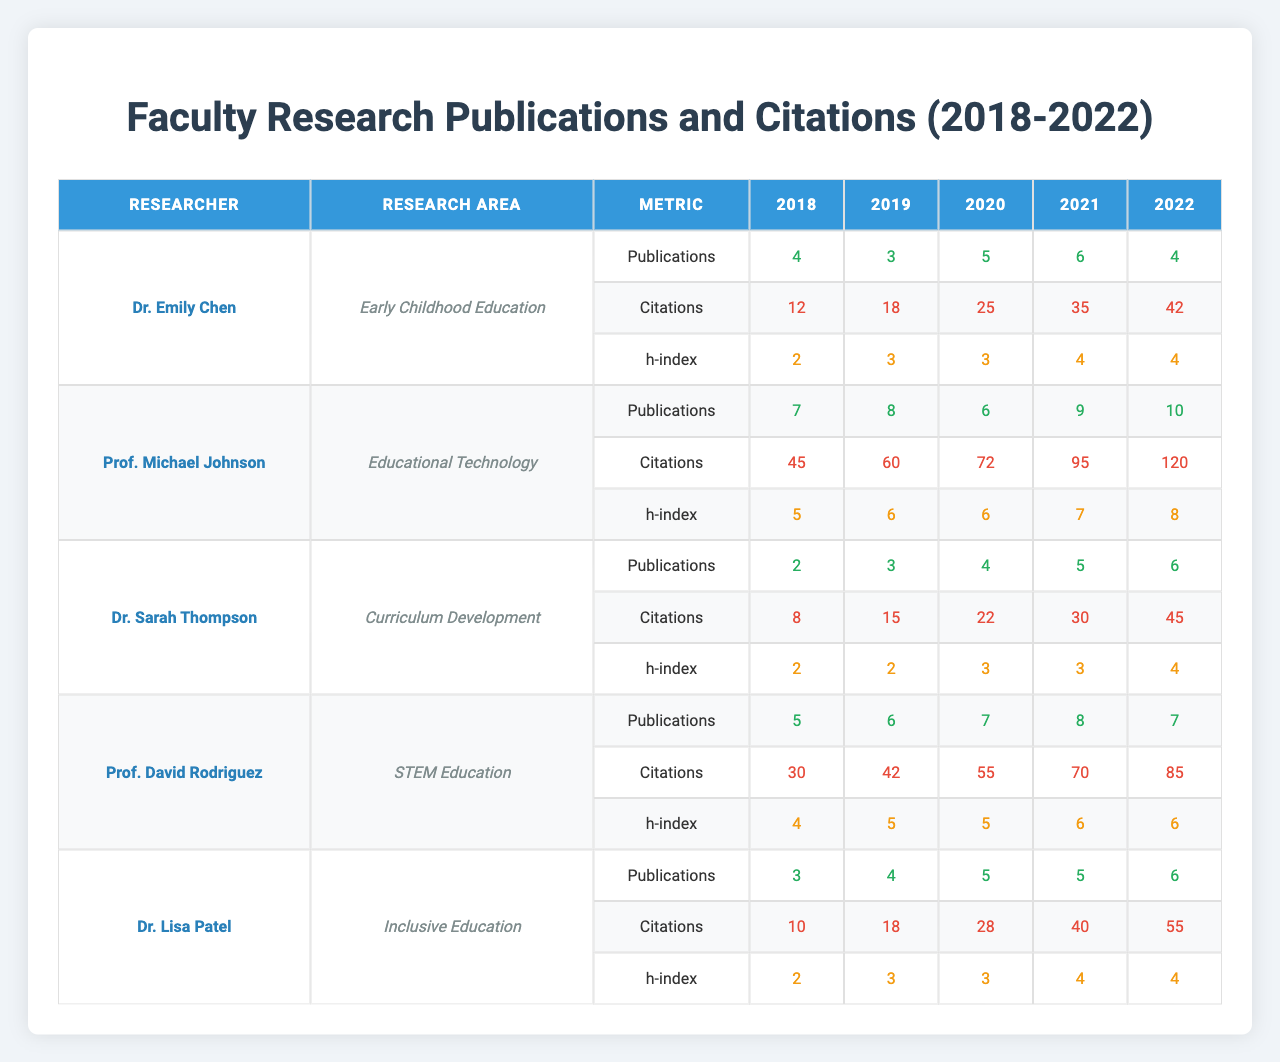What was the highest number of publications by any researcher in 2020? In 2020, the number of publications for each researcher is as follows: Dr. Emily Chen (5), Prof. Michael Johnson (6), Dr. Sarah Thompson (4), Prof. David Rodriguez (7), Dr. Lisa Patel (5). The highest publication count is 7 by Prof. David Rodriguez.
Answer: 7 Which researcher had the lowest total citation count over the five years? The total citations for each researcher are: Dr. Emily Chen (132), Prof. Michael Johnson (297), Dr. Sarah Thompson (120), Prof. David Rodriguez (342), Dr. Lisa Patel (151). The lowest total citation count is 120 by Dr. Sarah Thompson.
Answer: Dr. Sarah Thompson What is the average number of publications for Prof. Michael Johnson over the 5 years? Prof. Michael Johnson's publications are (7 + 8 + 6 + 9 + 10) = 40. To find the average, divide by 5, which gives 40/5 = 8.
Answer: 8 Did any researcher have an h-index of 6 in 2021? In 2021, the h-index values are: Dr. Emily Chen (4), Prof. Michael Johnson (7), Dr. Sarah Thompson (3), Prof. David Rodriguez (6), Dr. Lisa Patel (4). Yes, Prof. Michael Johnson and Prof. David Rodriguez had h-index values of 6 or greater (7 and 6 respectively).
Answer: Yes Which research area had the highest total publications when summed across all years? The total publications by research area are: Early Childhood Education (22), Educational Technology (40), Curriculum Development (20), STEM Education (35), Inclusive Education (27). Educational Technology has the highest total with 40 publications.
Answer: Educational Technology What was the percentage increase in citations for Dr. Lisa Patel from 2018 to 2022? Dr. Lisa Patel's citations for 2018 is 10 and for 2022 is 55. The increase is 55 - 10 = 45. To find the percentage increase, divide 45 by 10 and multiply by 100 which gives (45 / 10) * 100 = 450%.
Answer: 450% After summing the total publications for each researcher, who had the smallest sum? The total publications for each researcher are: Dr. Emily Chen (22), Prof. Michael Johnson (40), Dr. Sarah Thompson (20), Prof. David Rodriguez (35), Dr. Lisa Patel (28). The smallest total is 20 by Dr. Sarah Thompson.
Answer: Dr. Sarah Thompson Which researcher consistently increased their number of publications over the 5 years? Looking at the publication counts: Dr. Emily Chen (4, 3, 5, 6, 4), Prof. Michael Johnson (7, 8, 6, 9, 10), Dr. Sarah Thompson (2, 3, 4, 5, 6), Prof. David Rodriguez (5, 6, 7, 8, 7), Dr. Lisa Patel (3, 4, 5, 5, 6). Dr. Sarah Thompson showed a consistent increase (2 to 6).
Answer: Dr. Sarah Thompson What is the total publications and citations of Dr. Emily Chen across the 5 years? Dr. Emily Chen's publications are 22 (4+3+5+6+4) and citations are 132 (12+18+25+35+42). Therefore, total publications and citations are 22 and 132 respectively.
Answer: 22 publications and 132 citations 